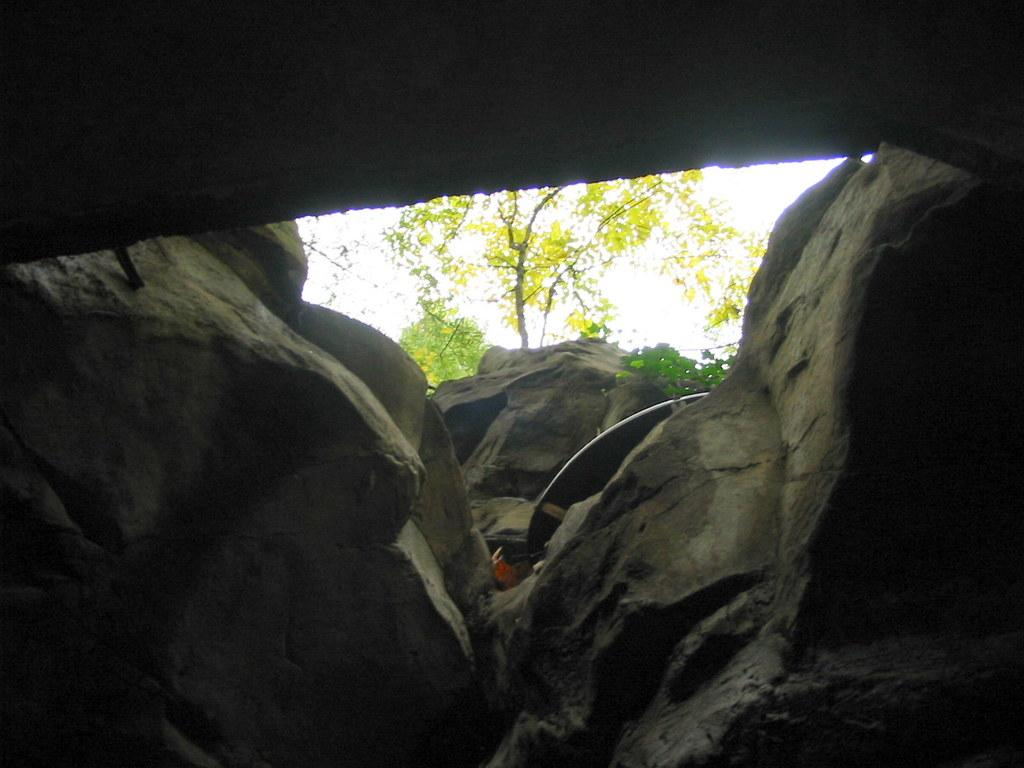What type of natural formation can be seen in the image? There are rocks in the image. Can you describe the unspecified object in the image? Unfortunately, the facts provided do not give any details about the unspecified object, so we cannot describe it. What is visible in the background of the image? There is a tree and the sky visible in the background of the image. How many chickens are perched on the rocks in the image? There are no chickens present in the image; it only features rocks, an unspecified object, a tree, and the sky. What type of quiver is visible in the image? There is no quiver present in the image. 